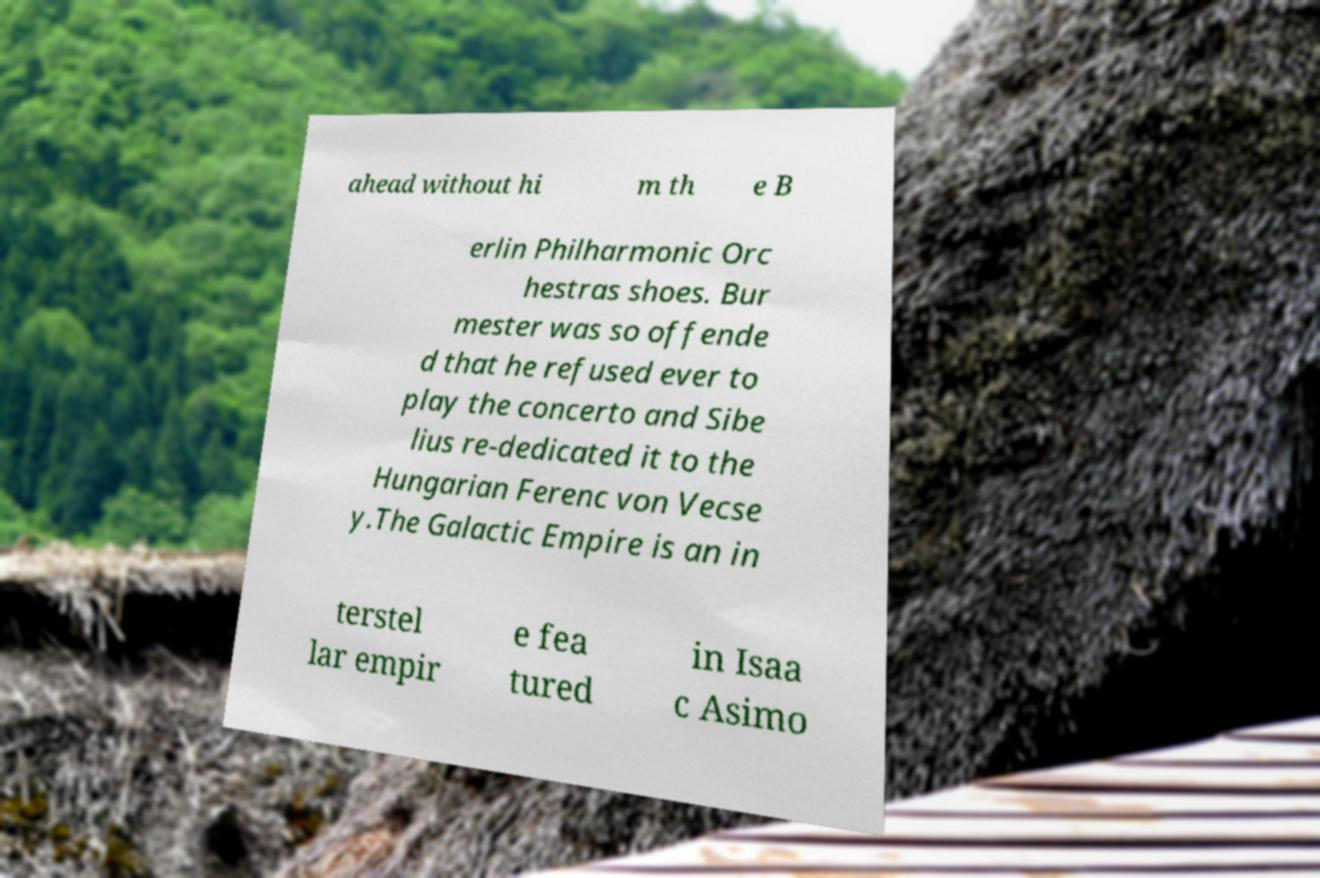Could you assist in decoding the text presented in this image and type it out clearly? ahead without hi m th e B erlin Philharmonic Orc hestras shoes. Bur mester was so offende d that he refused ever to play the concerto and Sibe lius re-dedicated it to the Hungarian Ferenc von Vecse y.The Galactic Empire is an in terstel lar empir e fea tured in Isaa c Asimo 